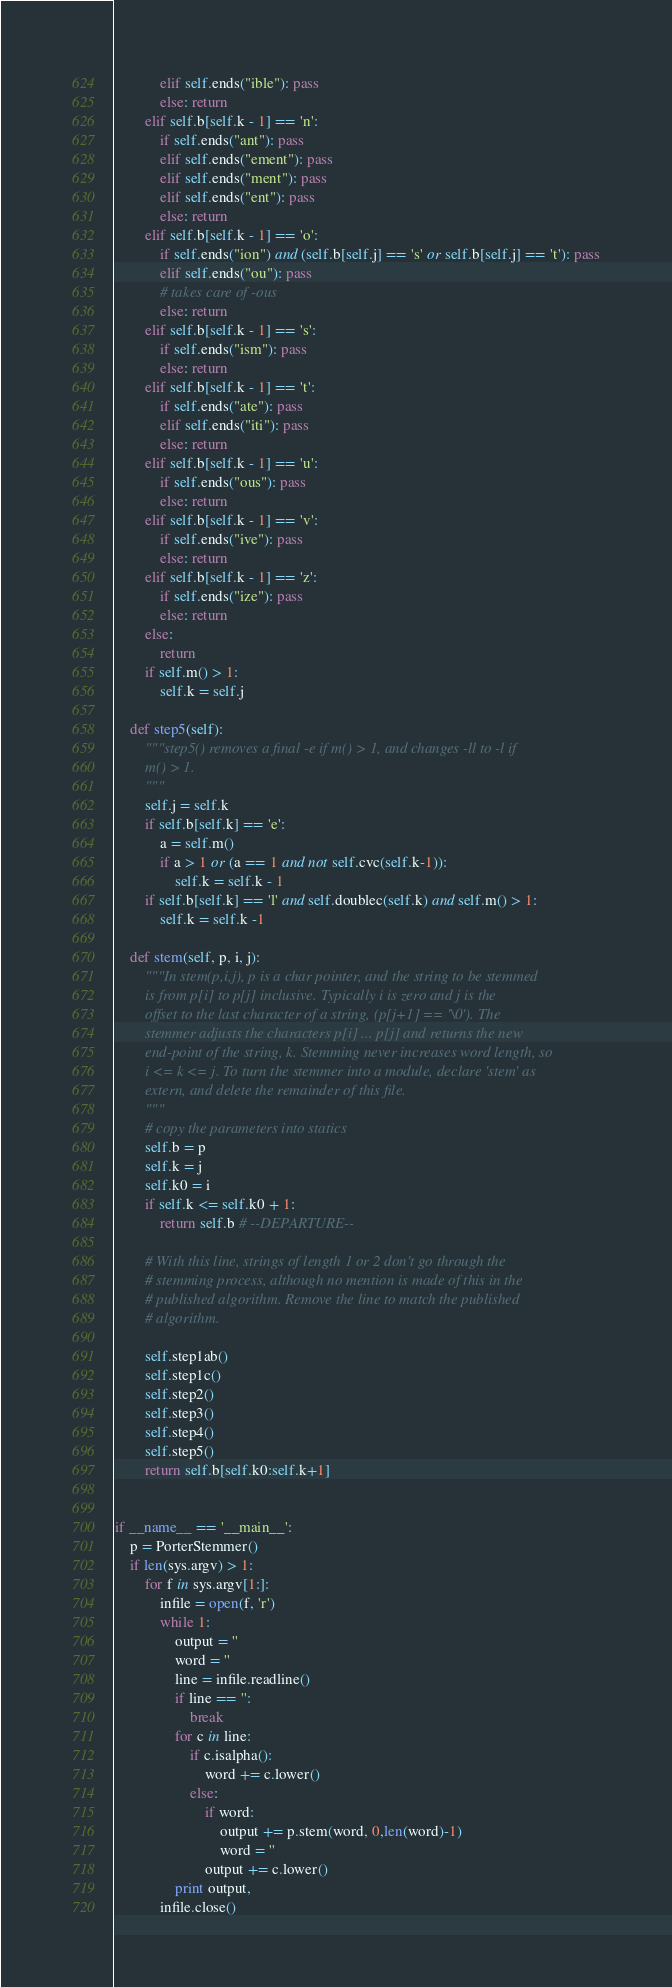<code> <loc_0><loc_0><loc_500><loc_500><_Python_>            elif self.ends("ible"): pass
            else: return
        elif self.b[self.k - 1] == 'n':
            if self.ends("ant"): pass
            elif self.ends("ement"): pass
            elif self.ends("ment"): pass
            elif self.ends("ent"): pass
            else: return
        elif self.b[self.k - 1] == 'o':
            if self.ends("ion") and (self.b[self.j] == 's' or self.b[self.j] == 't'): pass
            elif self.ends("ou"): pass
            # takes care of -ous
            else: return
        elif self.b[self.k - 1] == 's':
            if self.ends("ism"): pass
            else: return
        elif self.b[self.k - 1] == 't':
            if self.ends("ate"): pass
            elif self.ends("iti"): pass
            else: return
        elif self.b[self.k - 1] == 'u':
            if self.ends("ous"): pass
            else: return
        elif self.b[self.k - 1] == 'v':
            if self.ends("ive"): pass
            else: return
        elif self.b[self.k - 1] == 'z':
            if self.ends("ize"): pass
            else: return
        else:
            return
        if self.m() > 1:
            self.k = self.j

    def step5(self):
        """step5() removes a final -e if m() > 1, and changes -ll to -l if
        m() > 1.
        """
        self.j = self.k
        if self.b[self.k] == 'e':
            a = self.m()
            if a > 1 or (a == 1 and not self.cvc(self.k-1)):
                self.k = self.k - 1
        if self.b[self.k] == 'l' and self.doublec(self.k) and self.m() > 1:
            self.k = self.k -1

    def stem(self, p, i, j):
        """In stem(p,i,j), p is a char pointer, and the string to be stemmed
        is from p[i] to p[j] inclusive. Typically i is zero and j is the
        offset to the last character of a string, (p[j+1] == '\0'). The
        stemmer adjusts the characters p[i] ... p[j] and returns the new
        end-point of the string, k. Stemming never increases word length, so
        i <= k <= j. To turn the stemmer into a module, declare 'stem' as
        extern, and delete the remainder of this file.
        """
        # copy the parameters into statics
        self.b = p
        self.k = j
        self.k0 = i
        if self.k <= self.k0 + 1:
            return self.b # --DEPARTURE--

        # With this line, strings of length 1 or 2 don't go through the
        # stemming process, although no mention is made of this in the
        # published algorithm. Remove the line to match the published
        # algorithm.

        self.step1ab()
        self.step1c()
        self.step2()
        self.step3()
        self.step4()
        self.step5()
        return self.b[self.k0:self.k+1]


if __name__ == '__main__':
    p = PorterStemmer()
    if len(sys.argv) > 1:
        for f in sys.argv[1:]:
            infile = open(f, 'r')
            while 1:
                output = ''
                word = ''
                line = infile.readline()
                if line == '':
                    break
                for c in line:
                    if c.isalpha():
                        word += c.lower()
                    else:
                        if word:
                            output += p.stem(word, 0,len(word)-1)
                            word = ''
                        output += c.lower()
                print output,
            infile.close()
</code> 